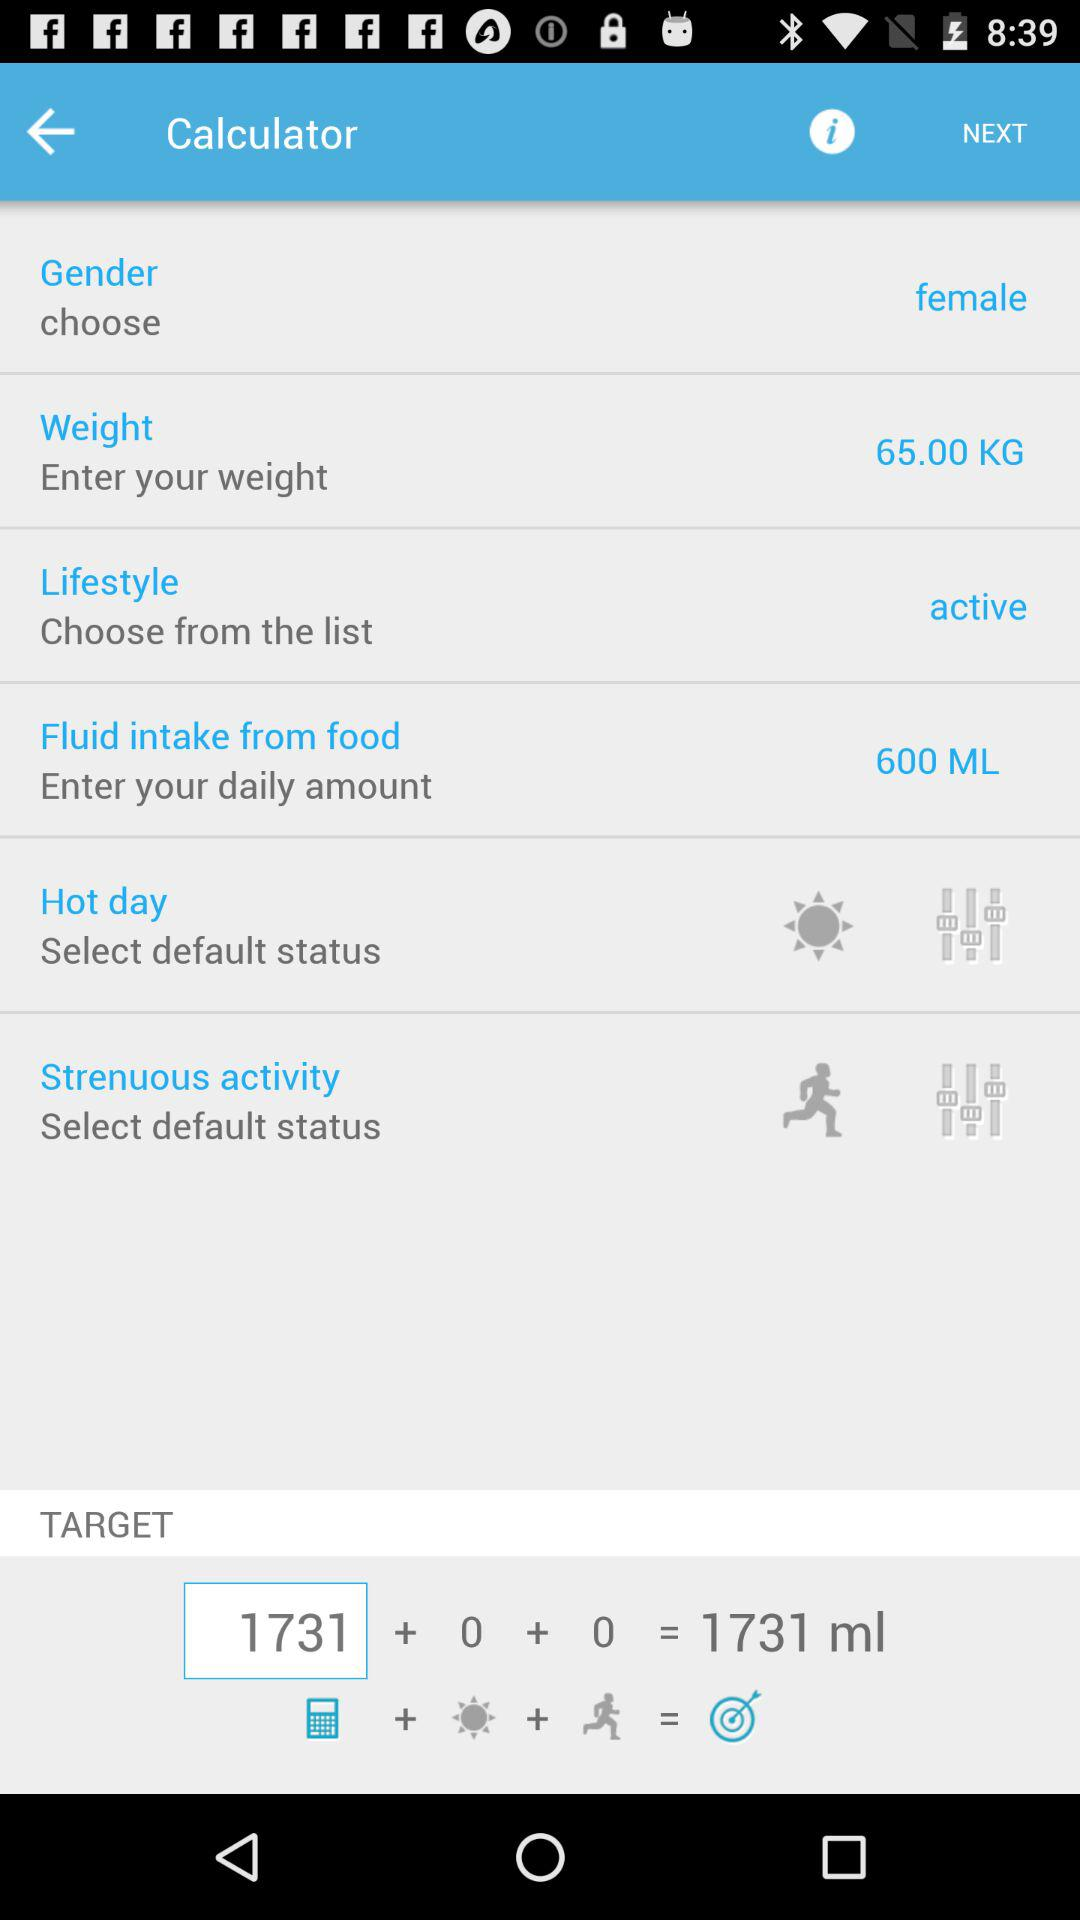What is the status of "Lifestyle"? The status of "Lifestyle" is "active". 